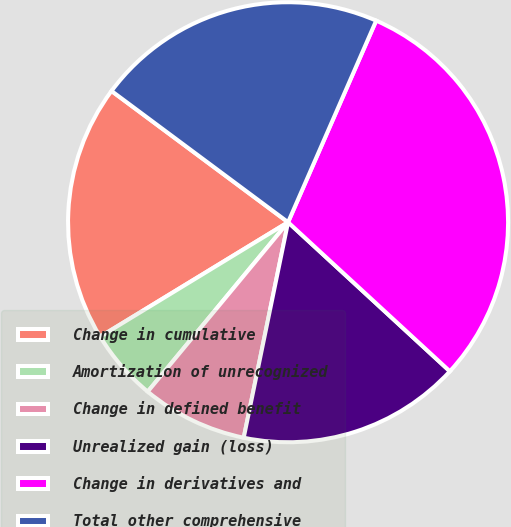Convert chart to OTSL. <chart><loc_0><loc_0><loc_500><loc_500><pie_chart><fcel>Change in cumulative<fcel>Amortization of unrecognized<fcel>Change in defined benefit<fcel>Unrealized gain (loss)<fcel>Change in derivatives and<fcel>Total other comprehensive<nl><fcel>18.88%<fcel>5.28%<fcel>7.78%<fcel>16.38%<fcel>30.29%<fcel>21.38%<nl></chart> 